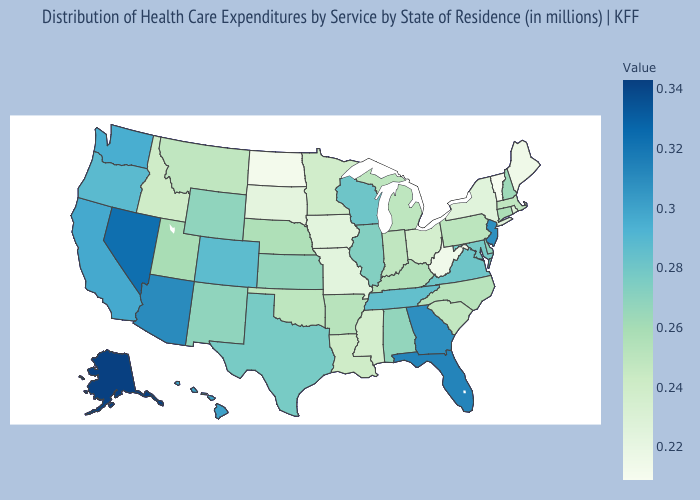Among the states that border Minnesota , does North Dakota have the lowest value?
Give a very brief answer. Yes. Does Florida have a higher value than Alaska?
Keep it brief. No. Which states have the highest value in the USA?
Give a very brief answer. Alaska. Which states have the lowest value in the USA?
Write a very short answer. Vermont. Is the legend a continuous bar?
Write a very short answer. Yes. Among the states that border Oklahoma , does Missouri have the lowest value?
Short answer required. Yes. Among the states that border Alabama , does Mississippi have the lowest value?
Answer briefly. Yes. 